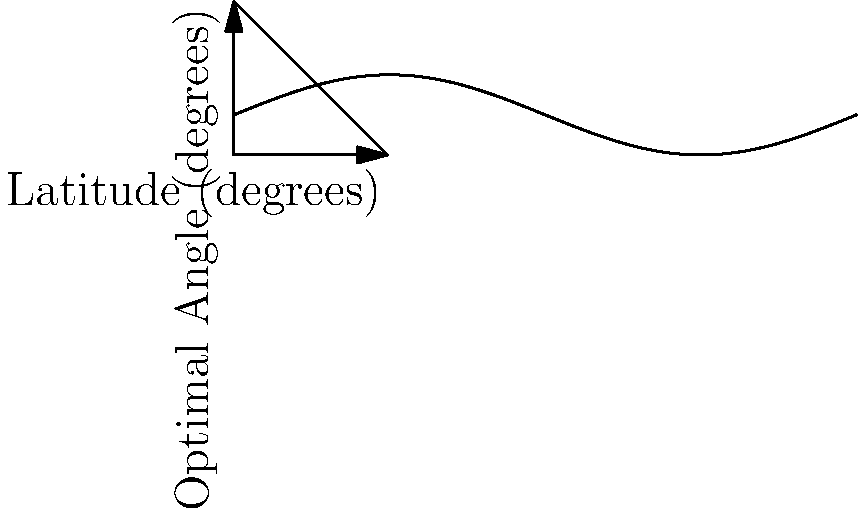As a startup founder developing solar solutions, you're optimizing panel installations across various locations. Using the provided sun path diagram and latitude-angle relationship, determine the optimal tilt angle for a solar panel installation at a latitude of 45°N. How does this angle relate to maximizing energy capture throughout the year? To determine the optimal tilt angle for a solar panel at 45°N latitude, we'll follow these steps:

1. Understand the graph:
   - X-axis represents latitude (0° to 90°)
   - Y-axis represents optimal angle (0° to 90°)
   - The straight line shows the relationship between latitude and optimal angle
   - The curved line represents the sun's path throughout the year

2. Locate the point on the graph:
   - Find 45° on the x-axis (latitude)
   - Move vertically to the straight line
   - This intersection point (labeled 'A') gives us the optimal angle

3. Read the optimal angle:
   - From point 'A', move horizontally to the y-axis
   - The optimal angle is approximately 45°

4. Understand the relationship:
   - The graph shows that the optimal angle is roughly equal to the latitude
   - This can be expressed as: $\text{Optimal Angle} \approx \text{Latitude}$

5. Explain energy maximization:
   - This angle maximizes annual energy capture by:
     a) Capturing more direct sunlight during winter when the sun is lower
     b) Reducing overexposure during summer when the sun is higher
   - The curved line (sun path) shows seasonal variations
   - The 45° tilt is a compromise between summer and winter sun positions

6. Consider practical applications:
   - In real-world scenarios, factors like local weather patterns, shading, and specific energy demand periods might slightly adjust this angle
   - For a startup, this provides a good rule of thumb for quick estimations across different locations
Answer: 45°, approximately equal to the latitude 